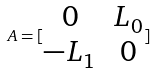<formula> <loc_0><loc_0><loc_500><loc_500>A = [ \begin{matrix} 0 & L _ { 0 } \\ - L _ { 1 } & 0 \end{matrix} ]</formula> 